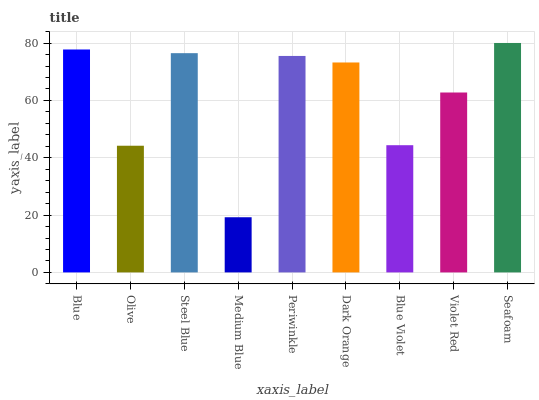Is Medium Blue the minimum?
Answer yes or no. Yes. Is Seafoam the maximum?
Answer yes or no. Yes. Is Olive the minimum?
Answer yes or no. No. Is Olive the maximum?
Answer yes or no. No. Is Blue greater than Olive?
Answer yes or no. Yes. Is Olive less than Blue?
Answer yes or no. Yes. Is Olive greater than Blue?
Answer yes or no. No. Is Blue less than Olive?
Answer yes or no. No. Is Dark Orange the high median?
Answer yes or no. Yes. Is Dark Orange the low median?
Answer yes or no. Yes. Is Seafoam the high median?
Answer yes or no. No. Is Violet Red the low median?
Answer yes or no. No. 